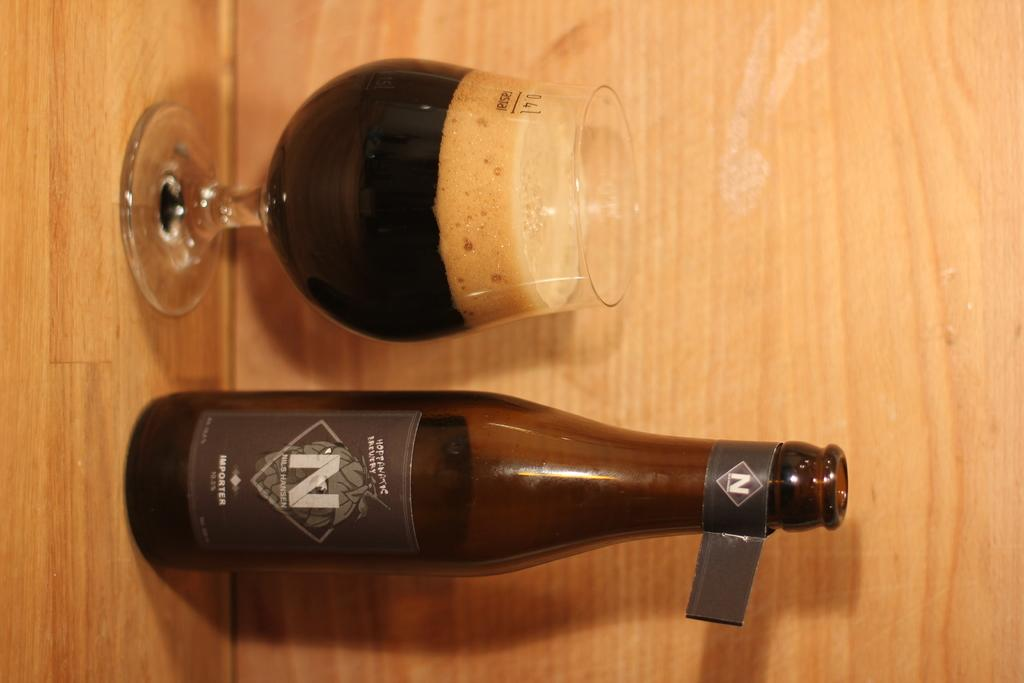What is in the glass that is visible in the image? There is a drink in the glass in the image. What else can be seen in the image besides the glass? There is a bottle in the image. Where are the glass and bottle located in the image? The glass and bottle are placed on a platform. How many fingers can be seen touching the glass in the image? There are no fingers visible touching the glass in the image. 